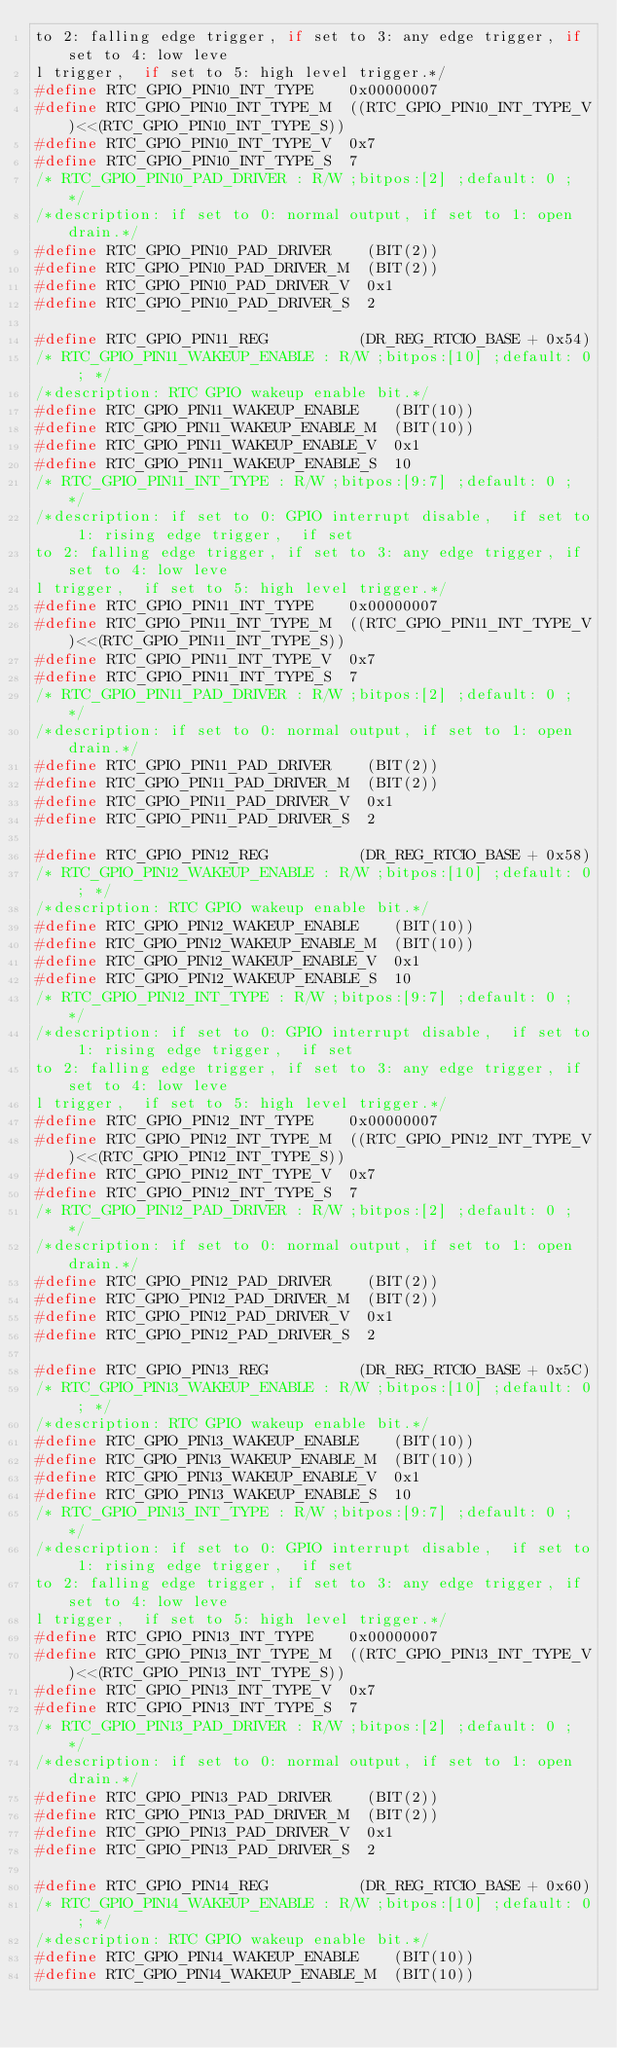<code> <loc_0><loc_0><loc_500><loc_500><_C_>to 2: falling edge trigger, if set to 3: any edge trigger, if set to 4: low leve
l trigger,  if set to 5: high level trigger.*/
#define RTC_GPIO_PIN10_INT_TYPE    0x00000007
#define RTC_GPIO_PIN10_INT_TYPE_M  ((RTC_GPIO_PIN10_INT_TYPE_V)<<(RTC_GPIO_PIN10_INT_TYPE_S))
#define RTC_GPIO_PIN10_INT_TYPE_V  0x7
#define RTC_GPIO_PIN10_INT_TYPE_S  7
/* RTC_GPIO_PIN10_PAD_DRIVER : R/W ;bitpos:[2] ;default: 0 ; */
/*description: if set to 0: normal output, if set to 1: open drain.*/
#define RTC_GPIO_PIN10_PAD_DRIVER    (BIT(2))
#define RTC_GPIO_PIN10_PAD_DRIVER_M  (BIT(2))
#define RTC_GPIO_PIN10_PAD_DRIVER_V  0x1
#define RTC_GPIO_PIN10_PAD_DRIVER_S  2

#define RTC_GPIO_PIN11_REG          (DR_REG_RTCIO_BASE + 0x54)
/* RTC_GPIO_PIN11_WAKEUP_ENABLE : R/W ;bitpos:[10] ;default: 0 ; */
/*description: RTC GPIO wakeup enable bit.*/
#define RTC_GPIO_PIN11_WAKEUP_ENABLE    (BIT(10))
#define RTC_GPIO_PIN11_WAKEUP_ENABLE_M  (BIT(10))
#define RTC_GPIO_PIN11_WAKEUP_ENABLE_V  0x1
#define RTC_GPIO_PIN11_WAKEUP_ENABLE_S  10
/* RTC_GPIO_PIN11_INT_TYPE : R/W ;bitpos:[9:7] ;default: 0 ; */
/*description: if set to 0: GPIO interrupt disable,  if set to 1: rising edge trigger,  if set
to 2: falling edge trigger, if set to 3: any edge trigger, if set to 4: low leve
l trigger,  if set to 5: high level trigger.*/
#define RTC_GPIO_PIN11_INT_TYPE    0x00000007
#define RTC_GPIO_PIN11_INT_TYPE_M  ((RTC_GPIO_PIN11_INT_TYPE_V)<<(RTC_GPIO_PIN11_INT_TYPE_S))
#define RTC_GPIO_PIN11_INT_TYPE_V  0x7
#define RTC_GPIO_PIN11_INT_TYPE_S  7
/* RTC_GPIO_PIN11_PAD_DRIVER : R/W ;bitpos:[2] ;default: 0 ; */
/*description: if set to 0: normal output, if set to 1: open drain.*/
#define RTC_GPIO_PIN11_PAD_DRIVER    (BIT(2))
#define RTC_GPIO_PIN11_PAD_DRIVER_M  (BIT(2))
#define RTC_GPIO_PIN11_PAD_DRIVER_V  0x1
#define RTC_GPIO_PIN11_PAD_DRIVER_S  2

#define RTC_GPIO_PIN12_REG          (DR_REG_RTCIO_BASE + 0x58)
/* RTC_GPIO_PIN12_WAKEUP_ENABLE : R/W ;bitpos:[10] ;default: 0 ; */
/*description: RTC GPIO wakeup enable bit.*/
#define RTC_GPIO_PIN12_WAKEUP_ENABLE    (BIT(10))
#define RTC_GPIO_PIN12_WAKEUP_ENABLE_M  (BIT(10))
#define RTC_GPIO_PIN12_WAKEUP_ENABLE_V  0x1
#define RTC_GPIO_PIN12_WAKEUP_ENABLE_S  10
/* RTC_GPIO_PIN12_INT_TYPE : R/W ;bitpos:[9:7] ;default: 0 ; */
/*description: if set to 0: GPIO interrupt disable,  if set to 1: rising edge trigger,  if set
to 2: falling edge trigger, if set to 3: any edge trigger, if set to 4: low leve
l trigger,  if set to 5: high level trigger.*/
#define RTC_GPIO_PIN12_INT_TYPE    0x00000007
#define RTC_GPIO_PIN12_INT_TYPE_M  ((RTC_GPIO_PIN12_INT_TYPE_V)<<(RTC_GPIO_PIN12_INT_TYPE_S))
#define RTC_GPIO_PIN12_INT_TYPE_V  0x7
#define RTC_GPIO_PIN12_INT_TYPE_S  7
/* RTC_GPIO_PIN12_PAD_DRIVER : R/W ;bitpos:[2] ;default: 0 ; */
/*description: if set to 0: normal output, if set to 1: open drain.*/
#define RTC_GPIO_PIN12_PAD_DRIVER    (BIT(2))
#define RTC_GPIO_PIN12_PAD_DRIVER_M  (BIT(2))
#define RTC_GPIO_PIN12_PAD_DRIVER_V  0x1
#define RTC_GPIO_PIN12_PAD_DRIVER_S  2

#define RTC_GPIO_PIN13_REG          (DR_REG_RTCIO_BASE + 0x5C)
/* RTC_GPIO_PIN13_WAKEUP_ENABLE : R/W ;bitpos:[10] ;default: 0 ; */
/*description: RTC GPIO wakeup enable bit.*/
#define RTC_GPIO_PIN13_WAKEUP_ENABLE    (BIT(10))
#define RTC_GPIO_PIN13_WAKEUP_ENABLE_M  (BIT(10))
#define RTC_GPIO_PIN13_WAKEUP_ENABLE_V  0x1
#define RTC_GPIO_PIN13_WAKEUP_ENABLE_S  10
/* RTC_GPIO_PIN13_INT_TYPE : R/W ;bitpos:[9:7] ;default: 0 ; */
/*description: if set to 0: GPIO interrupt disable,  if set to 1: rising edge trigger,  if set
to 2: falling edge trigger, if set to 3: any edge trigger, if set to 4: low leve
l trigger,  if set to 5: high level trigger.*/
#define RTC_GPIO_PIN13_INT_TYPE    0x00000007
#define RTC_GPIO_PIN13_INT_TYPE_M  ((RTC_GPIO_PIN13_INT_TYPE_V)<<(RTC_GPIO_PIN13_INT_TYPE_S))
#define RTC_GPIO_PIN13_INT_TYPE_V  0x7
#define RTC_GPIO_PIN13_INT_TYPE_S  7
/* RTC_GPIO_PIN13_PAD_DRIVER : R/W ;bitpos:[2] ;default: 0 ; */
/*description: if set to 0: normal output, if set to 1: open drain.*/
#define RTC_GPIO_PIN13_PAD_DRIVER    (BIT(2))
#define RTC_GPIO_PIN13_PAD_DRIVER_M  (BIT(2))
#define RTC_GPIO_PIN13_PAD_DRIVER_V  0x1
#define RTC_GPIO_PIN13_PAD_DRIVER_S  2

#define RTC_GPIO_PIN14_REG          (DR_REG_RTCIO_BASE + 0x60)
/* RTC_GPIO_PIN14_WAKEUP_ENABLE : R/W ;bitpos:[10] ;default: 0 ; */
/*description: RTC GPIO wakeup enable bit.*/
#define RTC_GPIO_PIN14_WAKEUP_ENABLE    (BIT(10))
#define RTC_GPIO_PIN14_WAKEUP_ENABLE_M  (BIT(10))</code> 